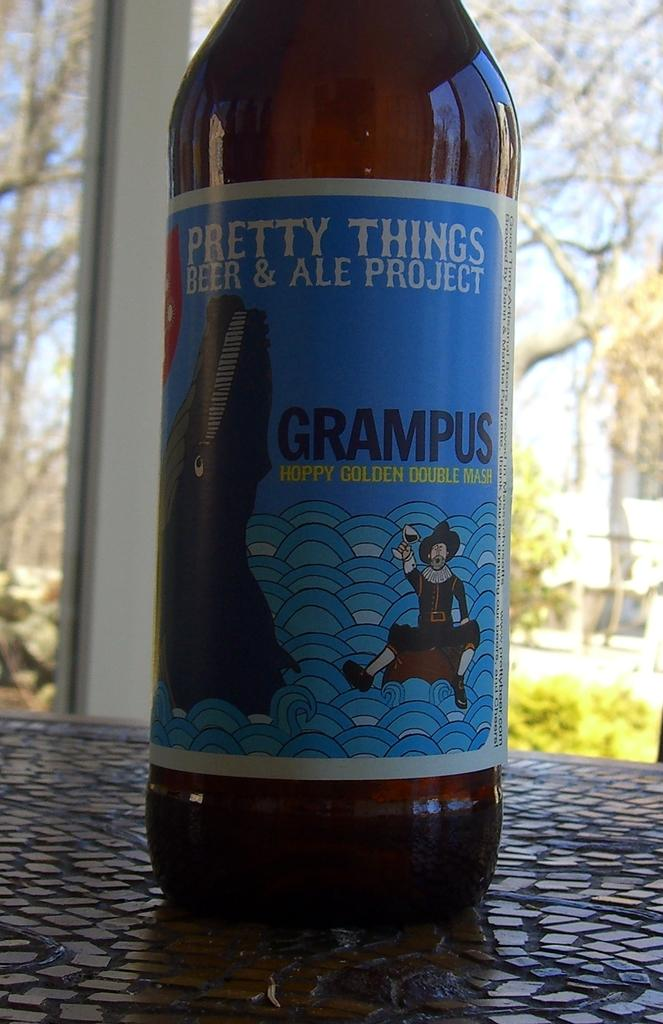<image>
Offer a succinct explanation of the picture presented. A bottle of Grampus ale sitting on a table outside 